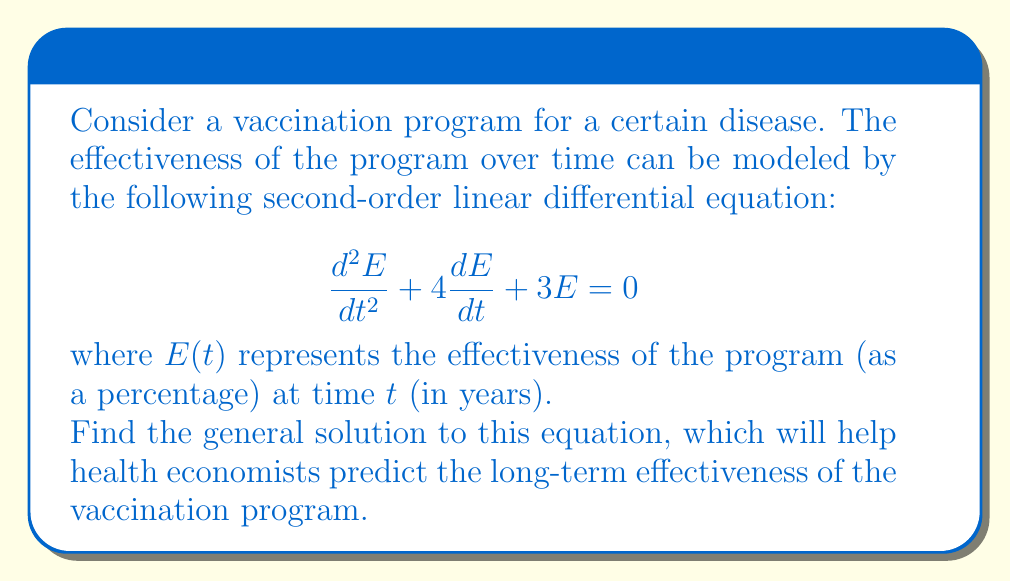Can you solve this math problem? To solve this second-order linear homogeneous differential equation, we follow these steps:

1) First, we assume a solution of the form $E(t) = e^{rt}$, where $r$ is a constant.

2) Substituting this into the original equation:
   
   $$r^2e^{rt} + 4re^{rt} + 3e^{rt} = 0$$

3) Factoring out $e^{rt}$:
   
   $$e^{rt}(r^2 + 4r + 3) = 0$$

4) Since $e^{rt} \neq 0$ for any real $t$, we solve the characteristic equation:
   
   $$r^2 + 4r + 3 = 0$$

5) This is a quadratic equation. We can solve it using the quadratic formula:
   
   $$r = \frac{-b \pm \sqrt{b^2 - 4ac}}{2a}$$
   
   where $a=1$, $b=4$, and $c=3$

6) Substituting these values:
   
   $$r = \frac{-4 \pm \sqrt{16 - 12}}{2} = \frac{-4 \pm \sqrt{4}}{2} = \frac{-4 \pm 2}{2}$$

7) This gives us two roots:
   
   $$r_1 = \frac{-4 + 2}{2} = -1 \quad \text{and} \quad r_2 = \frac{-4 - 2}{2} = -3$$

8) The general solution is a linear combination of the two fundamental solutions:
   
   $$E(t) = c_1e^{-t} + c_2e^{-3t}$$

   where $c_1$ and $c_2$ are arbitrary constants.

This solution allows health economists to model the effectiveness of the vaccination program over time, with the constants $c_1$ and $c_2$ to be determined based on initial conditions or data from the program's implementation.
Answer: $E(t) = c_1e^{-t} + c_2e^{-3t}$ 